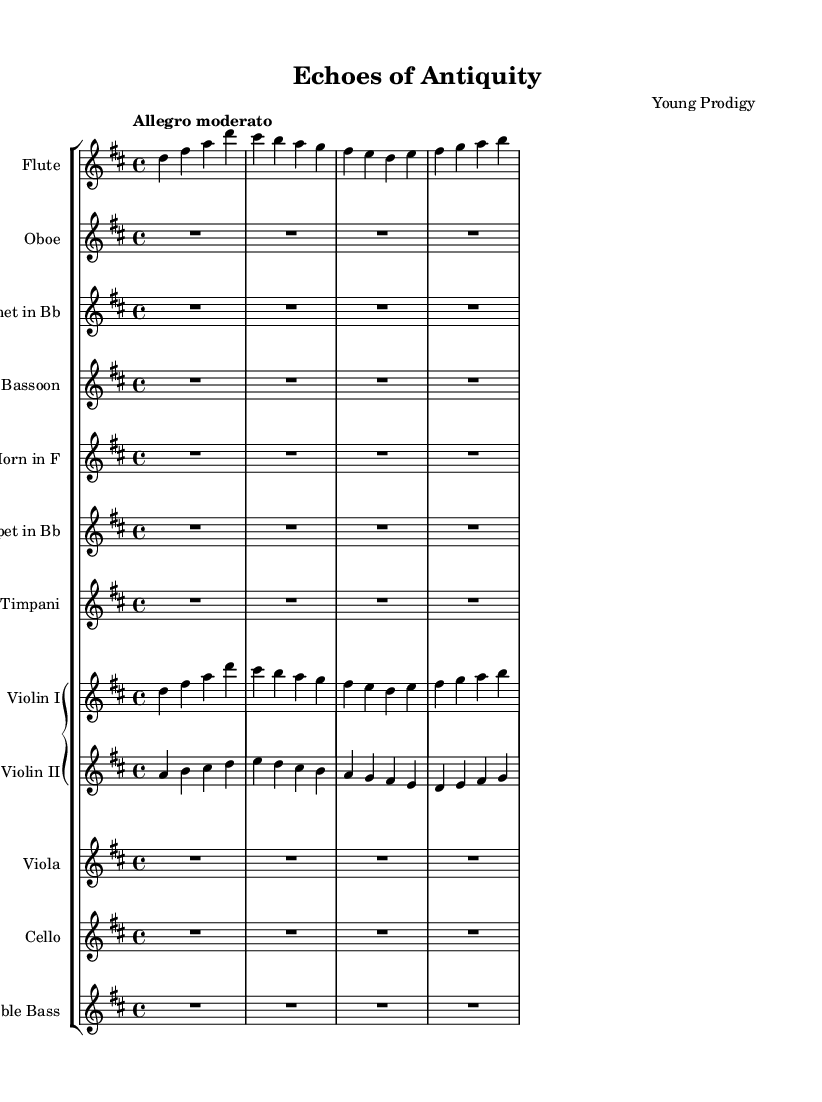What is the key signature of this music? The key signature is D major, which has two sharps (F# and C#). This can be identified by looking at the key signature indicated at the beginning of the score.
Answer: D major What is the time signature of this music? The time signature is 4/4, which indicates that there are four beats in each measure and the quarter note gets one beat. This is shown at the beginning of the score.
Answer: 4/4 What is the tempo marking for this piece? The tempo marking is "Allegro moderato," which suggests a moderately fast tempo. This is specified at the top of the score.
Answer: Allegro moderato Which instruments are featured as woodwinds? The woodwinds include the flute, oboe, clarinet, and bassoon, as they are clearly labeled in their respective staves. This categorization is standard in orchestral music.
Answer: Flute, oboe, clarinet, bassoon How many measures are there in the flute part? The flute part consists of four measures, as indicated by the number of bar lines present in the staff for the flute. Each measure is separated by vertical bar lines.
Answer: Four What is the highest note in the violin I part? The highest note in the violin I part is D, which can be found in the first measure of the staff. Observing the notes in the first measure shows the highest pitch present.
Answer: D What is the role of timpani in this symphony? Timpani typically plays a supportive role, providing rhythmic foundation and accentuating climactic moments. In this score, its part is marked with rests, indicating it may be featured sparsely.
Answer: Rhythmic foundation 